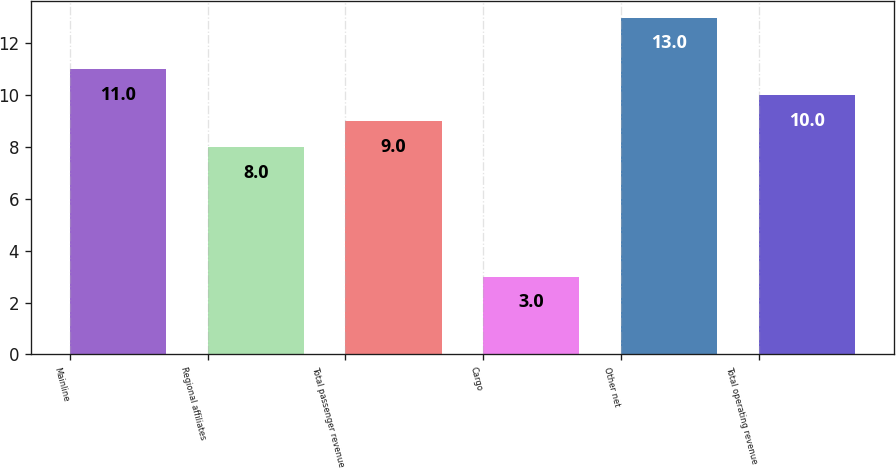<chart> <loc_0><loc_0><loc_500><loc_500><bar_chart><fcel>Mainline<fcel>Regional affiliates<fcel>Total passenger revenue<fcel>Cargo<fcel>Other net<fcel>Total operating revenue<nl><fcel>11<fcel>8<fcel>9<fcel>3<fcel>13<fcel>10<nl></chart> 